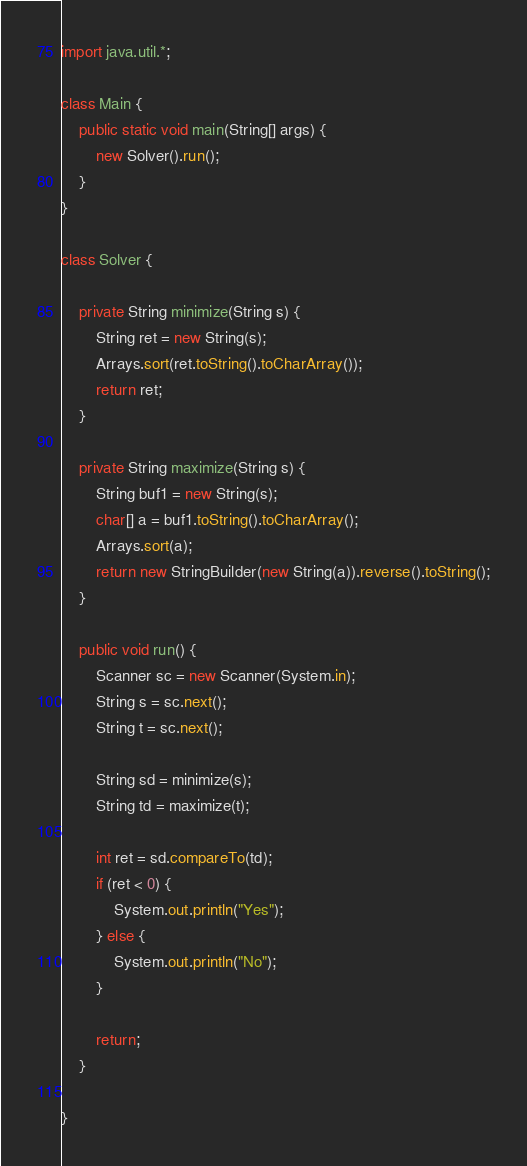Convert code to text. <code><loc_0><loc_0><loc_500><loc_500><_Java_>import java.util.*;

class Main {
    public static void main(String[] args) {
        new Solver().run();
    }
}

class Solver {

    private String minimize(String s) {
        String ret = new String(s);
        Arrays.sort(ret.toString().toCharArray());
        return ret;
    }

    private String maximize(String s) {
        String buf1 = new String(s);
        char[] a = buf1.toString().toCharArray();
        Arrays.sort(a);
        return new StringBuilder(new String(a)).reverse().toString();
    }

    public void run() {
        Scanner sc = new Scanner(System.in);
        String s = sc.next();
        String t = sc.next();

        String sd = minimize(s);
        String td = maximize(t);

        int ret = sd.compareTo(td);
        if (ret < 0) {
            System.out.println("Yes");
        } else {
            System.out.println("No");
        }

        return;
    }

}</code> 